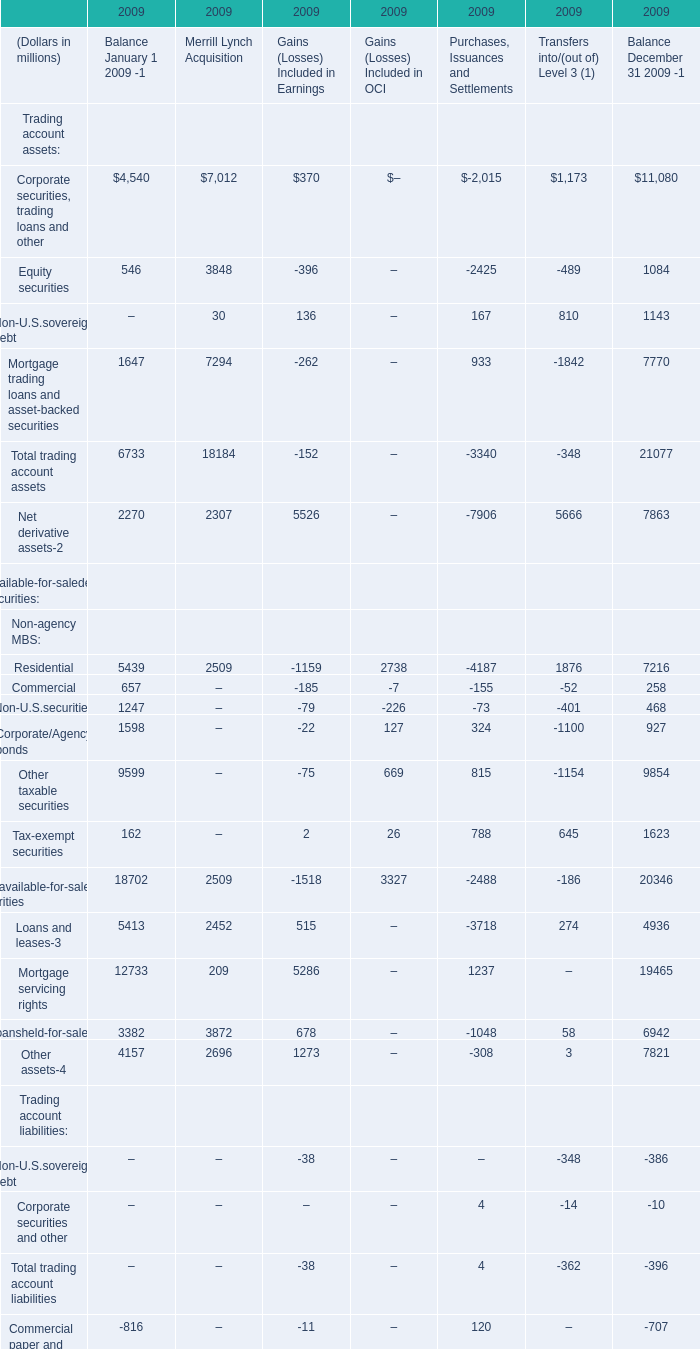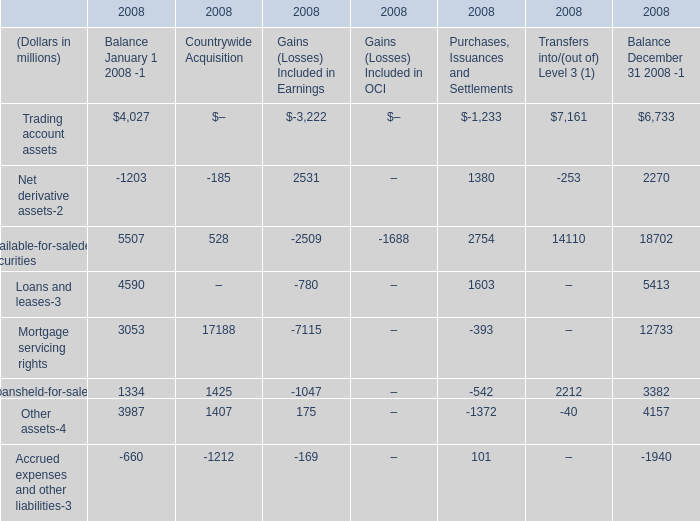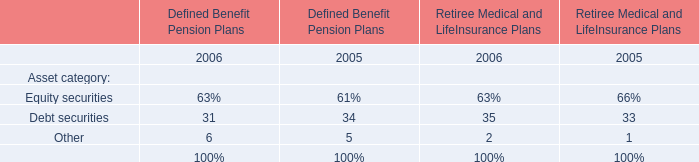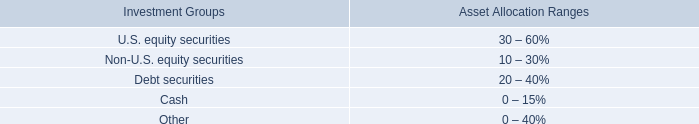What's the average of Trading account assets in terms of Balance January 1 2009 in 2009? (in dollars in millions) 
Computations: (6733 / 4)
Answer: 1683.25. 